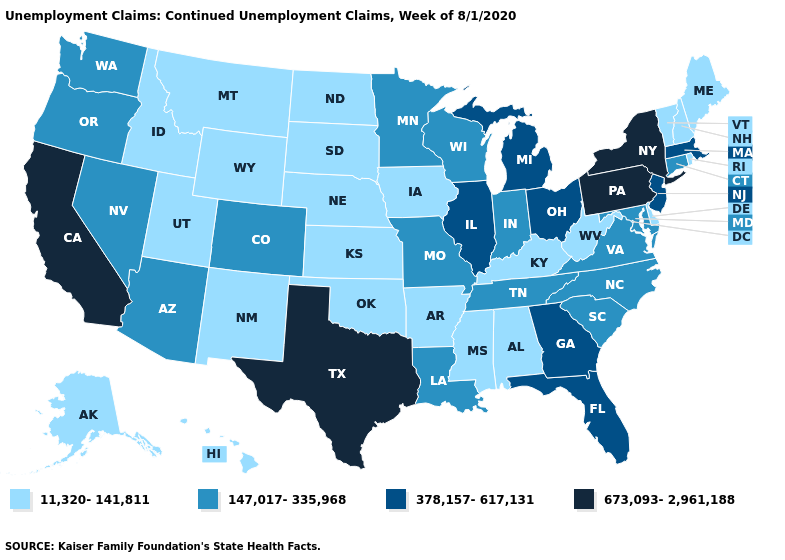Name the states that have a value in the range 673,093-2,961,188?
Be succinct. California, New York, Pennsylvania, Texas. What is the value of Kentucky?
Write a very short answer. 11,320-141,811. Which states have the lowest value in the USA?
Quick response, please. Alabama, Alaska, Arkansas, Delaware, Hawaii, Idaho, Iowa, Kansas, Kentucky, Maine, Mississippi, Montana, Nebraska, New Hampshire, New Mexico, North Dakota, Oklahoma, Rhode Island, South Dakota, Utah, Vermont, West Virginia, Wyoming. Name the states that have a value in the range 11,320-141,811?
Give a very brief answer. Alabama, Alaska, Arkansas, Delaware, Hawaii, Idaho, Iowa, Kansas, Kentucky, Maine, Mississippi, Montana, Nebraska, New Hampshire, New Mexico, North Dakota, Oklahoma, Rhode Island, South Dakota, Utah, Vermont, West Virginia, Wyoming. Name the states that have a value in the range 11,320-141,811?
Be succinct. Alabama, Alaska, Arkansas, Delaware, Hawaii, Idaho, Iowa, Kansas, Kentucky, Maine, Mississippi, Montana, Nebraska, New Hampshire, New Mexico, North Dakota, Oklahoma, Rhode Island, South Dakota, Utah, Vermont, West Virginia, Wyoming. What is the value of New Mexico?
Write a very short answer. 11,320-141,811. What is the value of Georgia?
Concise answer only. 378,157-617,131. What is the value of Alaska?
Answer briefly. 11,320-141,811. Which states have the lowest value in the Northeast?
Write a very short answer. Maine, New Hampshire, Rhode Island, Vermont. What is the value of Rhode Island?
Quick response, please. 11,320-141,811. Name the states that have a value in the range 378,157-617,131?
Concise answer only. Florida, Georgia, Illinois, Massachusetts, Michigan, New Jersey, Ohio. What is the lowest value in states that border New York?
Concise answer only. 11,320-141,811. Which states have the lowest value in the West?
Quick response, please. Alaska, Hawaii, Idaho, Montana, New Mexico, Utah, Wyoming. What is the lowest value in states that border Illinois?
Answer briefly. 11,320-141,811. Among the states that border Utah , does Wyoming have the highest value?
Be succinct. No. 